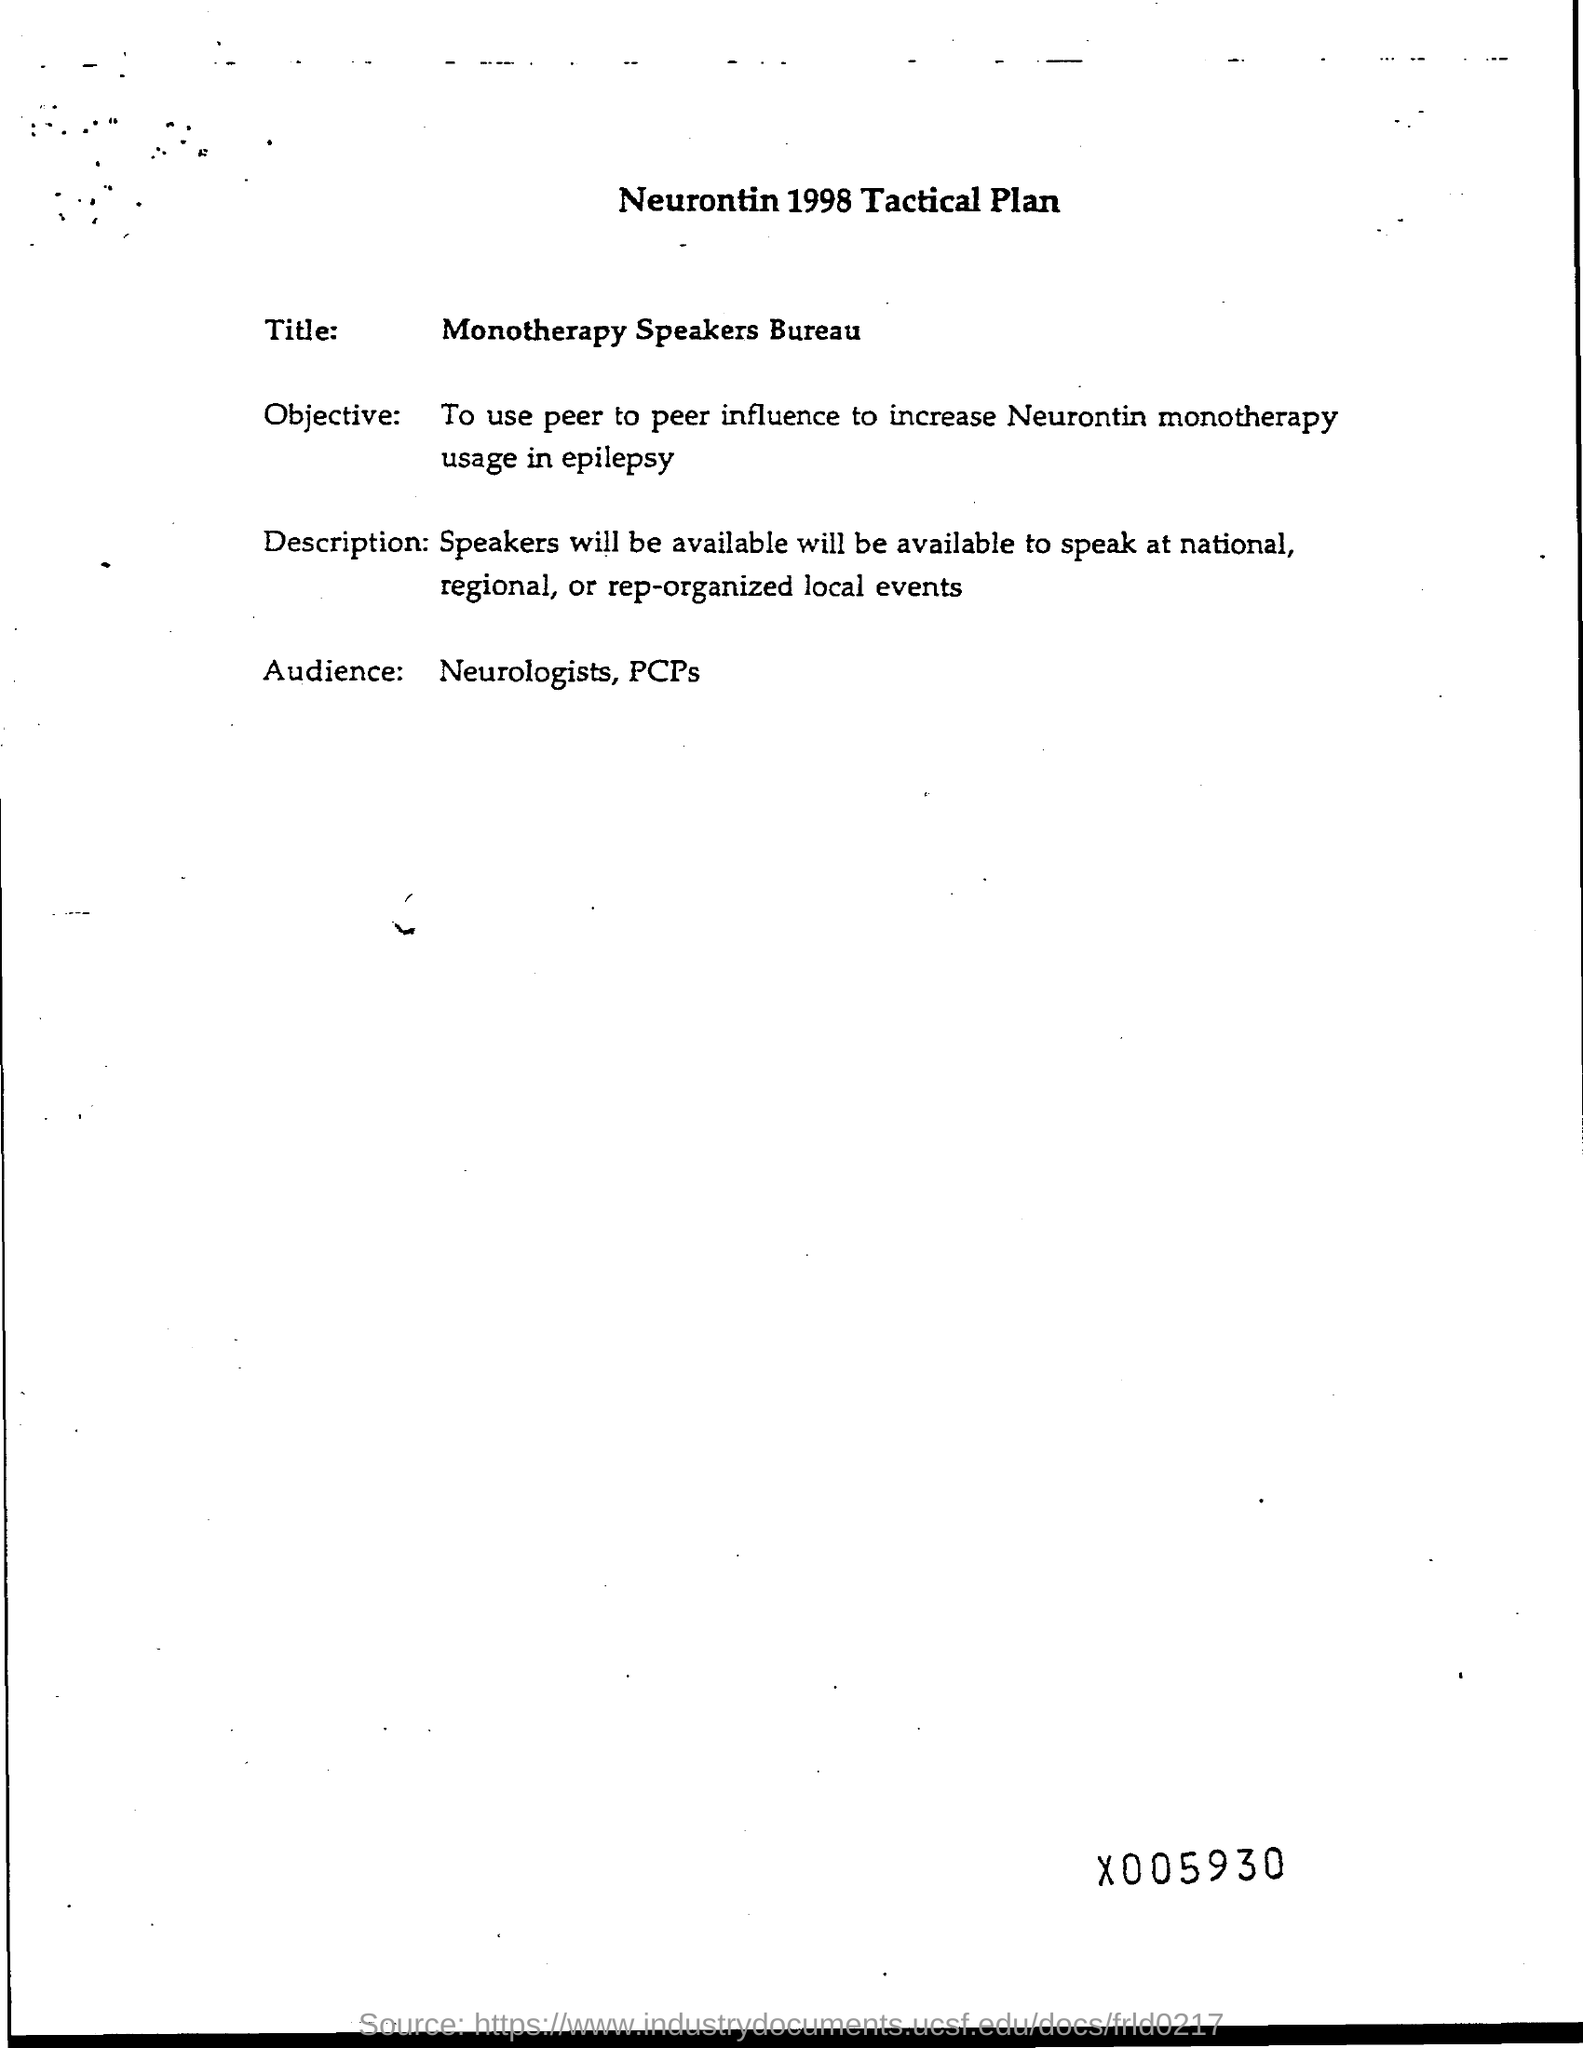What is the heading at top of the page ?
Offer a terse response. Neurontin 1998 tactical plan. Who are the audience ?
Provide a succinct answer. Neurologists , pcps. 